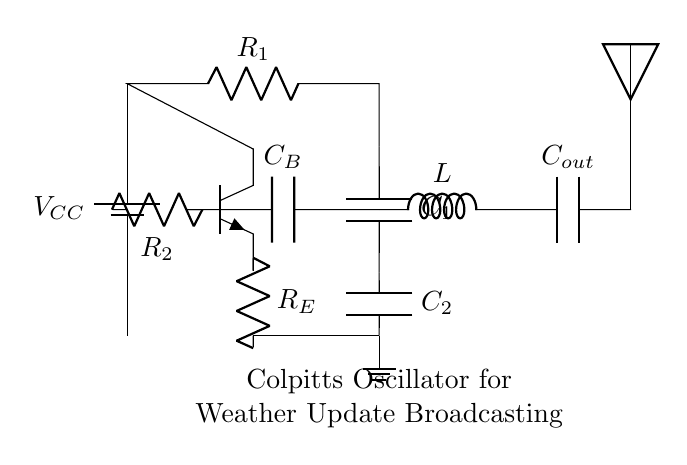What type of transistor is used in this circuit? The circuit diagram indicates an npn transistor is used. It is labeled as such in the diagram.
Answer: npn What is the role of capacitors in this oscillator? Capacitors are used for frequency determination in oscillators. In this circuit, they help set the oscillation frequency and ensure stability.
Answer: Frequency determination How many resistors are in this circuit? Counting the visual elements in the diagram shows there are three resistors labeled as R1, R2, and R_E.
Answer: three What is the purpose of the inductor in this Colpitts oscillator? The inductor is used in combination with the capacitors to form a tank circuit, which creates oscillations at a specific frequency.
Answer: Tank circuit What is the main function of this Colpitts oscillator circuit? This circuit is specifically designed to generate continuous waveforms for radio frequency broadcasting, important for transmitting weather updates.
Answer: Signal generation What is connected to the output of the oscillator? The output is connected to a capacitor labeled C_out and an antenna, which enables the transmission of the generated signals.
Answer: Antenna What voltage does the circuit operate on? The voltage source is labeled as V_CC, but the specific numerical value is not provided in the diagram. However, it typically denotes a positive supply voltage for the circuit.
Answer: V_CC 